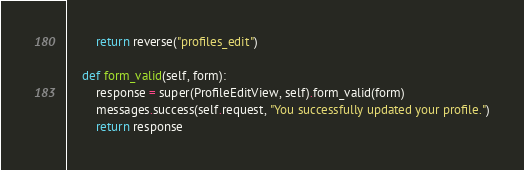Convert code to text. <code><loc_0><loc_0><loc_500><loc_500><_Python_>        return reverse("profiles_edit")

    def form_valid(self, form):
        response = super(ProfileEditView, self).form_valid(form)
        messages.success(self.request, "You successfully updated your profile.")
        return response
</code> 